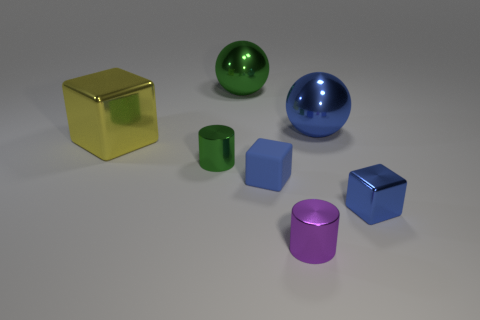Which objects are closest to each other? The small green cylinder and the small blue cube are closest to each other in the image, with both placed towards the bottom right-hand side, nearly touching. 